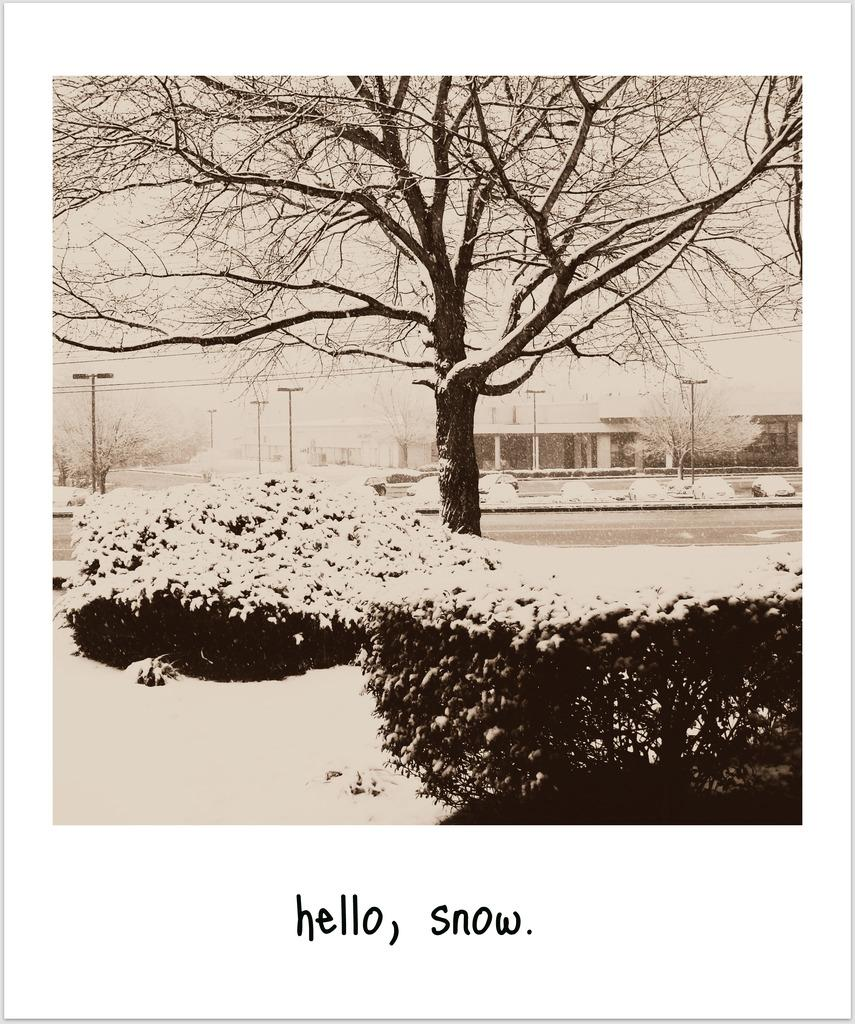What is the color scheme of the image? The image is black and white. What type of natural elements can be seen in the image? There are plants and trees in the image. What man-made structures are present in the image? There are poles and buildings in the image. Is there any text present in the image? Yes, there is text at the bottom of the image. What type of advertisement can be seen on the volleyball in the image? There is no volleyball present in the image, and therefore no advertisement can be seen on it. Can you describe the body language of the person in the image? There is no person present in the image, so it is not possible to describe their body language. 